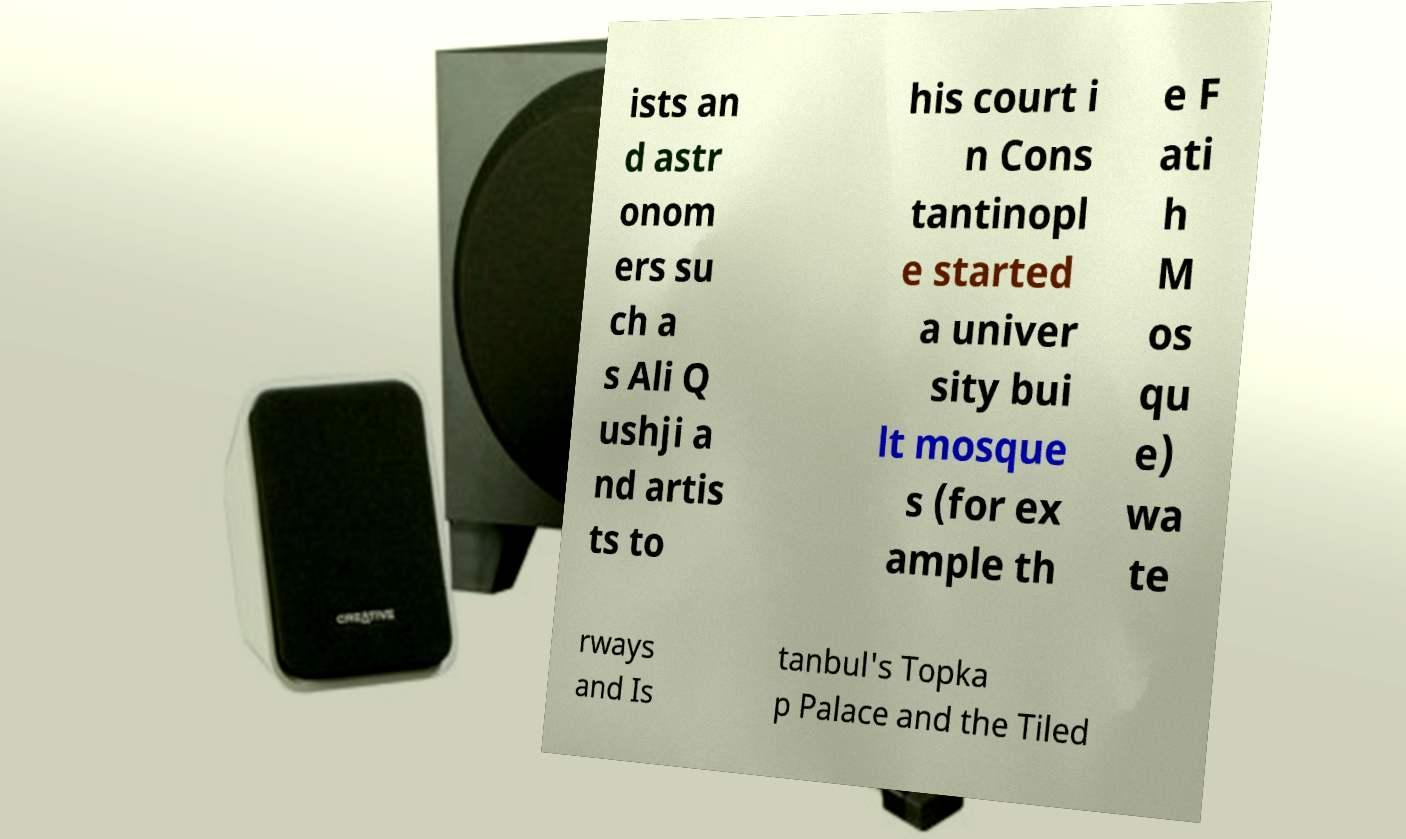What messages or text are displayed in this image? I need them in a readable, typed format. ists an d astr onom ers su ch a s Ali Q ushji a nd artis ts to his court i n Cons tantinopl e started a univer sity bui lt mosque s (for ex ample th e F ati h M os qu e) wa te rways and Is tanbul's Topka p Palace and the Tiled 